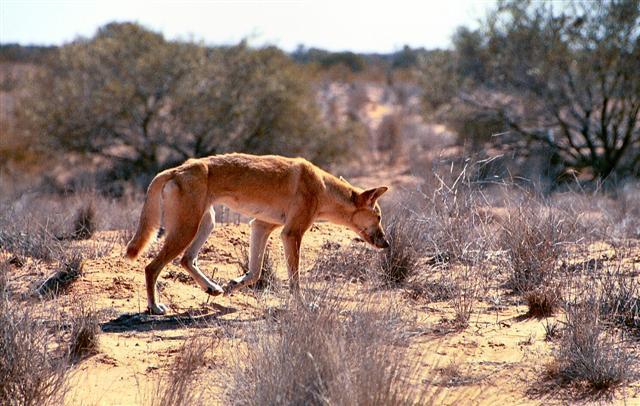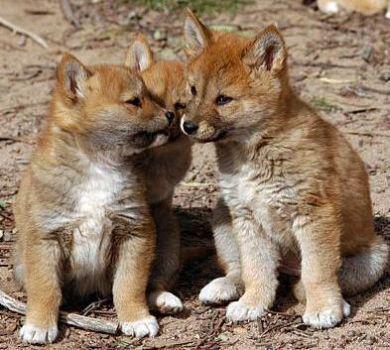The first image is the image on the left, the second image is the image on the right. Analyze the images presented: Is the assertion "The fox in the image on the left is standing in a barren sandy area." valid? Answer yes or no. Yes. The first image is the image on the left, the second image is the image on the right. Analyze the images presented: Is the assertion "There is only one dog in each picture." valid? Answer yes or no. No. 